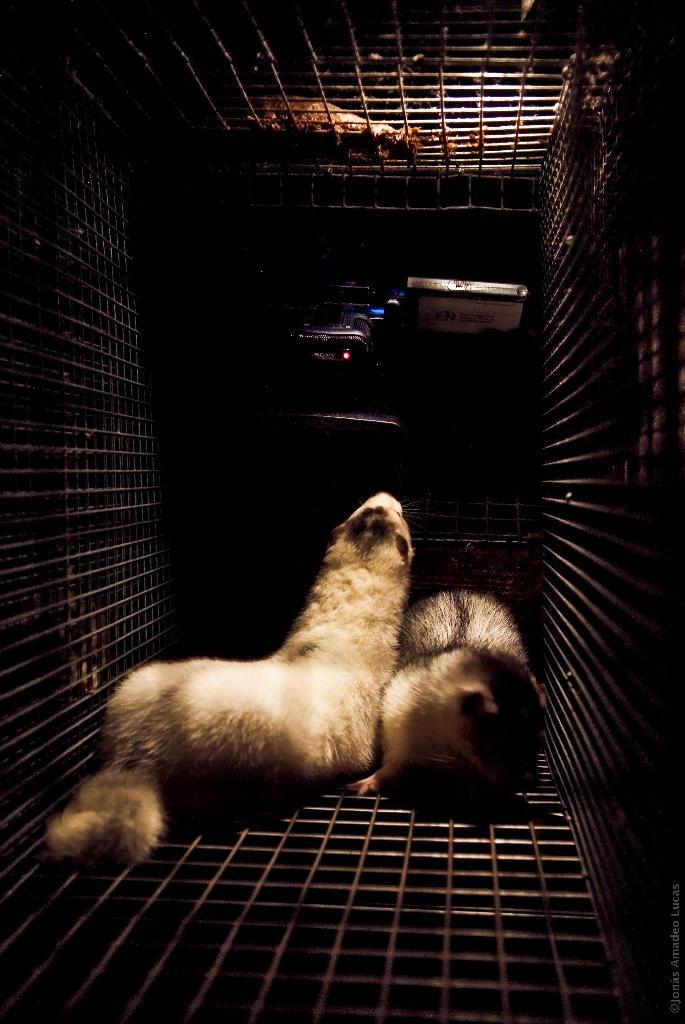How many animals are present in the image? There are two animals in the image. Where are the animals located? The animals are in a cage. Can you describe the background of the image? There are objects visible in the background of the image. What type of grass is growing inside the cage with the animals? There is no grass visible in the image; the animals are in a cage with objects in the background. 